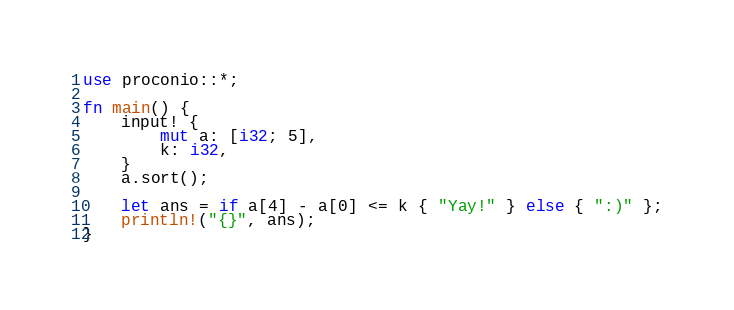Convert code to text. <code><loc_0><loc_0><loc_500><loc_500><_Rust_>use proconio::*;

fn main() {
    input! {
        mut a: [i32; 5],
        k: i32,
    }
    a.sort();

    let ans = if a[4] - a[0] <= k { "Yay!" } else { ":)" };
    println!("{}", ans);
}
</code> 